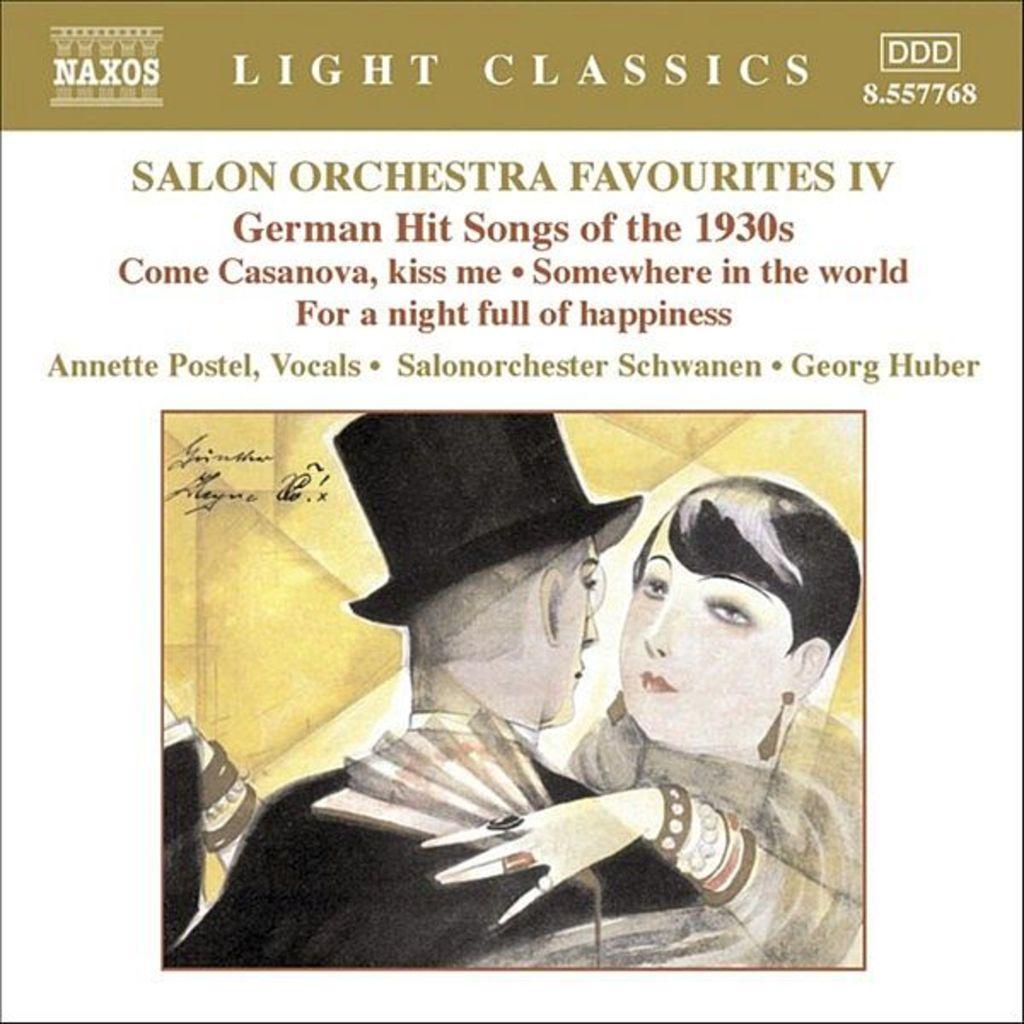How would you summarize this image in a sentence or two? In this image there is a painting of a woman and a man. At the top of the image there is some text written on it. 